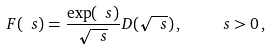Convert formula to latex. <formula><loc_0><loc_0><loc_500><loc_500>\ F ( \ s ) = \frac { \exp ( \ s ) } { \sqrt { \ s } } D ( \sqrt { \ s } ) \, , \quad \ s > 0 \, ,</formula> 